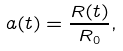<formula> <loc_0><loc_0><loc_500><loc_500>a ( t ) = \frac { R ( t ) } { R _ { 0 } } ,</formula> 